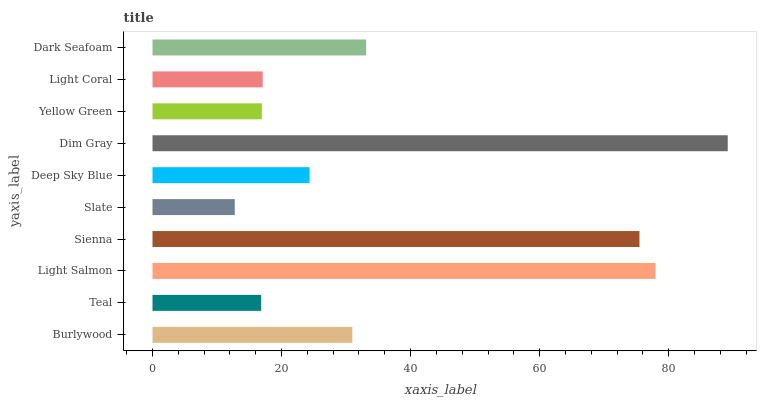Is Slate the minimum?
Answer yes or no. Yes. Is Dim Gray the maximum?
Answer yes or no. Yes. Is Teal the minimum?
Answer yes or no. No. Is Teal the maximum?
Answer yes or no. No. Is Burlywood greater than Teal?
Answer yes or no. Yes. Is Teal less than Burlywood?
Answer yes or no. Yes. Is Teal greater than Burlywood?
Answer yes or no. No. Is Burlywood less than Teal?
Answer yes or no. No. Is Burlywood the high median?
Answer yes or no. Yes. Is Deep Sky Blue the low median?
Answer yes or no. Yes. Is Slate the high median?
Answer yes or no. No. Is Burlywood the low median?
Answer yes or no. No. 